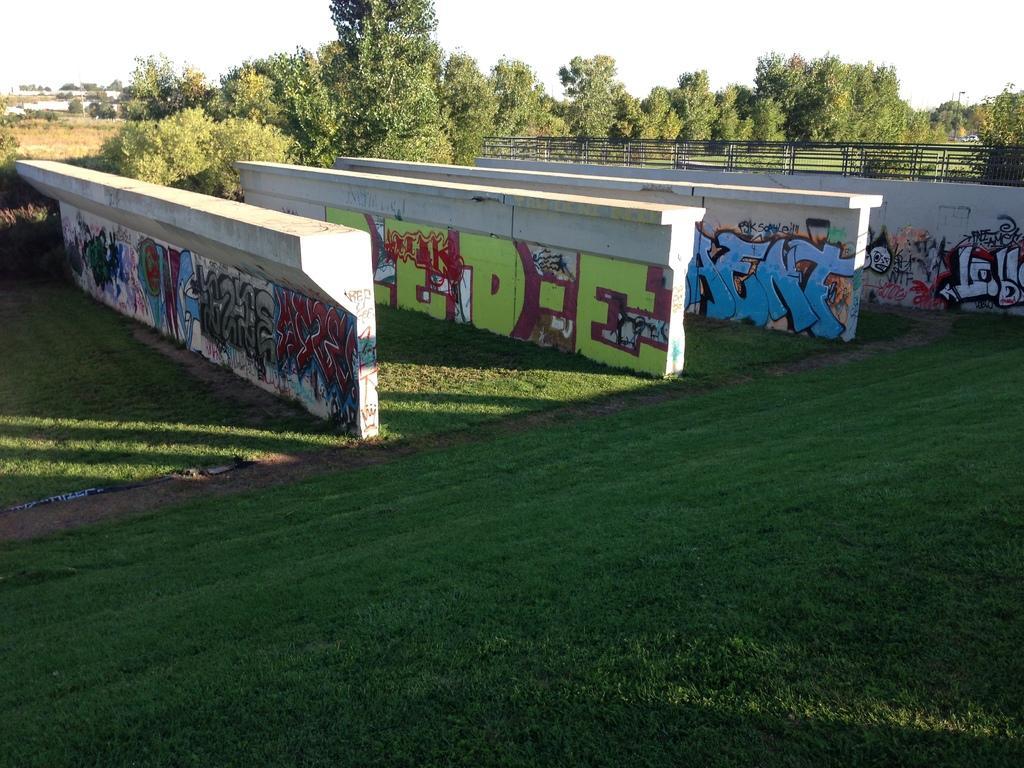How would you summarize this image in a sentence or two? In this image I can see walls. On the walls I can see paintings. Here I can see the grass. In the background I can see trees and the sky. 